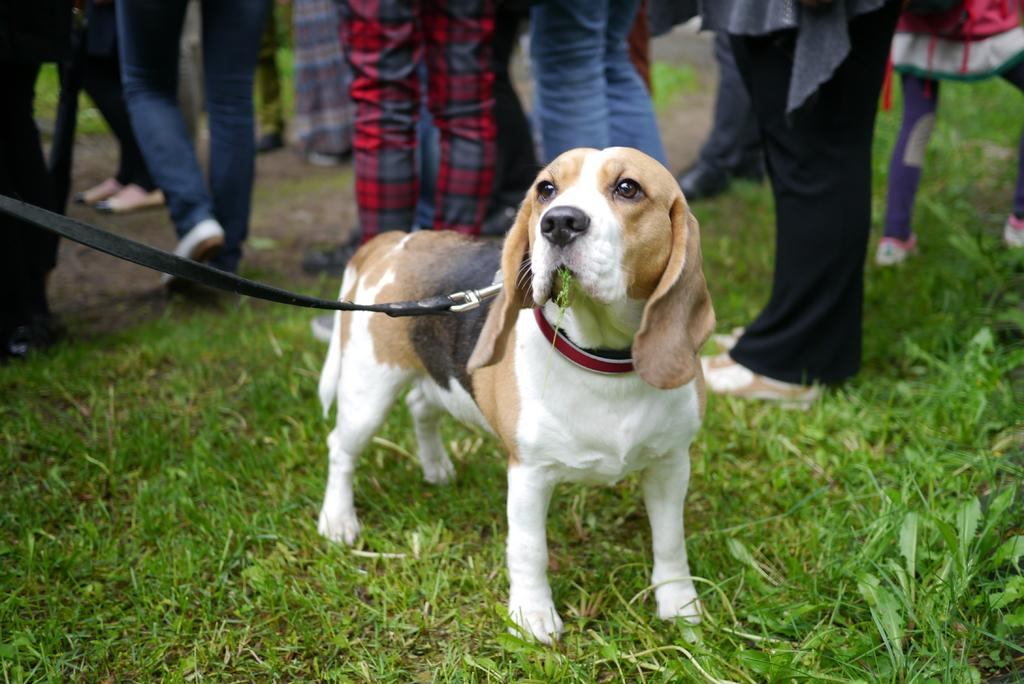What type of animal can be seen in the picture? There is a dog in the picture. What is the dog wearing? The dog is wearing a dog belt. What type of vegetation is present in the picture? There is grass and leaves in the picture. Can you describe the background of the picture? There is a group of people in the background of the picture. What type of peace symbol can be seen in the picture? There is no peace symbol present in the picture. Can you describe the house in the picture? There is no house present in the picture. 